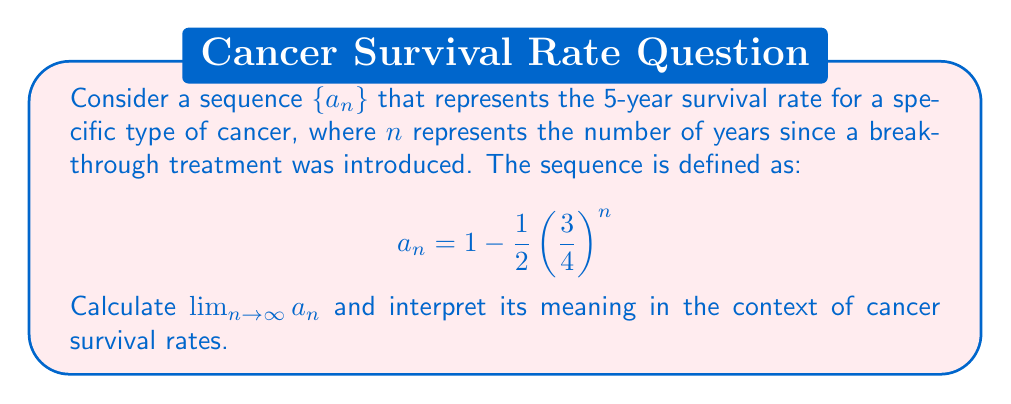Solve this math problem. To solve this problem, we'll follow these steps:

1) First, let's examine the sequence $a_n = 1 - \frac{1}{2} \left(\frac{3}{4}\right)^n$

2) As $n$ approaches infinity, we need to determine what happens to $\left(\frac{3}{4}\right)^n$

3) Since $0 < \frac{3}{4} < 1$, we know that $\lim_{n \to \infty} \left(\frac{3}{4}\right)^n = 0$

4) Now, let's apply the limit to the entire sequence:

   $\lim_{n \to \infty} a_n = \lim_{n \to \infty} \left(1 - \frac{1}{2} \left(\frac{3}{4}\right)^n\right)$

5) Using the limit laws, we can separate this:

   $\lim_{n \to \infty} a_n = \lim_{n \to \infty} 1 - \lim_{n \to \infty} \frac{1}{2} \left(\frac{3}{4}\right)^n$

6) We know that $\lim_{n \to \infty} 1 = 1$ and $\lim_{n \to \infty} \left(\frac{3}{4}\right)^n = 0$

7) Therefore:

   $\lim_{n \to \infty} a_n = 1 - \frac{1}{2} \cdot 0 = 1 - 0 = 1$

8) Interpretation: As $n$ approaches infinity, the 5-year survival rate approaches 100%. This means that as more time passes since the introduction of the breakthrough treatment, the survival rate for this specific type of cancer continues to improve, eventually approaching a perfect survival rate in the long term.
Answer: $\lim_{n \to \infty} a_n = 1$, which represents a long-term 5-year survival rate approaching 100% for this specific type of cancer. 